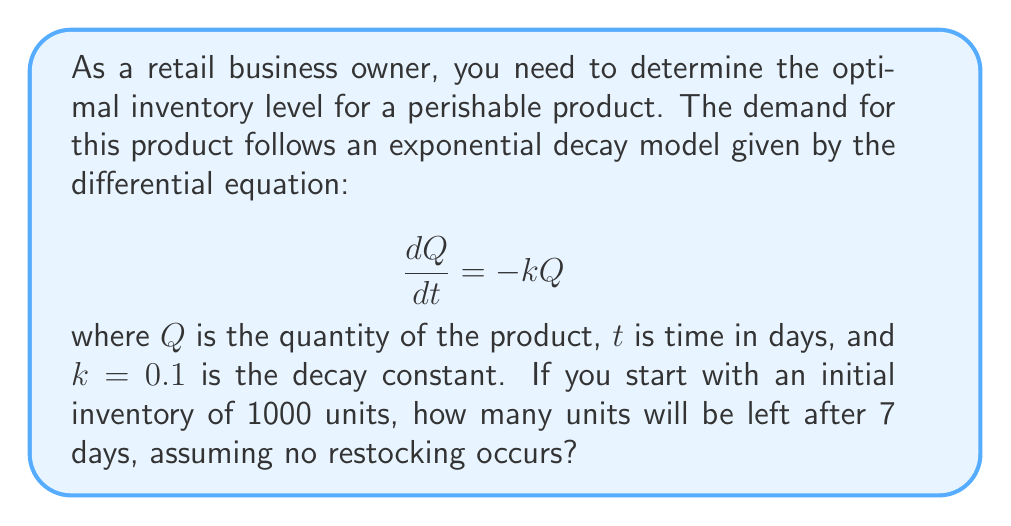Can you solve this math problem? To solve this problem, we need to use the solution to the exponential decay differential equation:

1) The general solution to the equation $\frac{dQ}{dt} = -kQ$ is:

   $$Q(t) = Q_0e^{-kt}$$

   where $Q_0$ is the initial quantity.

2) We are given:
   - Initial quantity $Q_0 = 1000$ units
   - Decay constant $k = 0.1$
   - Time $t = 7$ days

3) Substituting these values into the equation:

   $$Q(7) = 1000e^{-0.1 \cdot 7}$$

4) Simplify the exponent:
   
   $$Q(7) = 1000e^{-0.7}$$

5) Calculate the result:
   
   $$Q(7) = 1000 \cdot 0.4966 \approx 496.6$$

6) Since we're dealing with physical units, we round down to the nearest whole number.
Answer: 496 units 